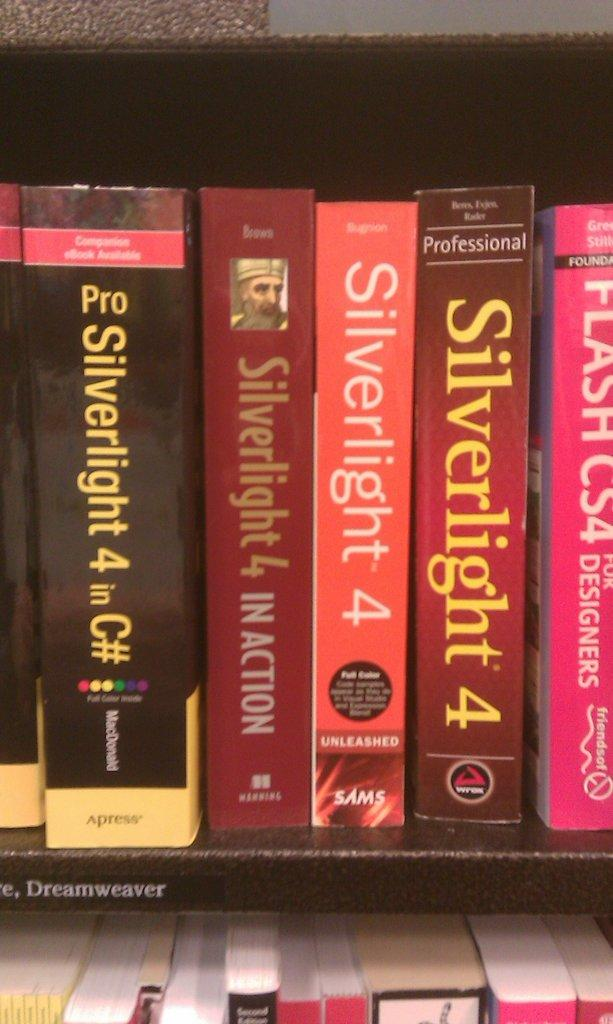Provide a one-sentence caption for the provided image. Several books on the same subject, called Silverlight 4. 